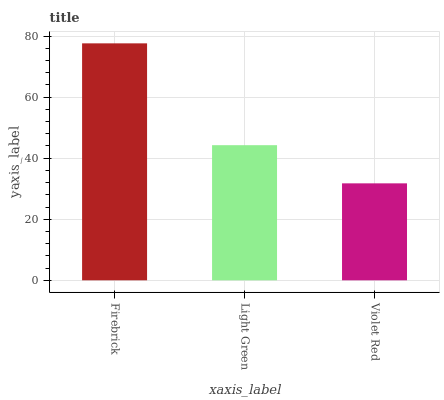Is Light Green the minimum?
Answer yes or no. No. Is Light Green the maximum?
Answer yes or no. No. Is Firebrick greater than Light Green?
Answer yes or no. Yes. Is Light Green less than Firebrick?
Answer yes or no. Yes. Is Light Green greater than Firebrick?
Answer yes or no. No. Is Firebrick less than Light Green?
Answer yes or no. No. Is Light Green the high median?
Answer yes or no. Yes. Is Light Green the low median?
Answer yes or no. Yes. Is Violet Red the high median?
Answer yes or no. No. Is Violet Red the low median?
Answer yes or no. No. 